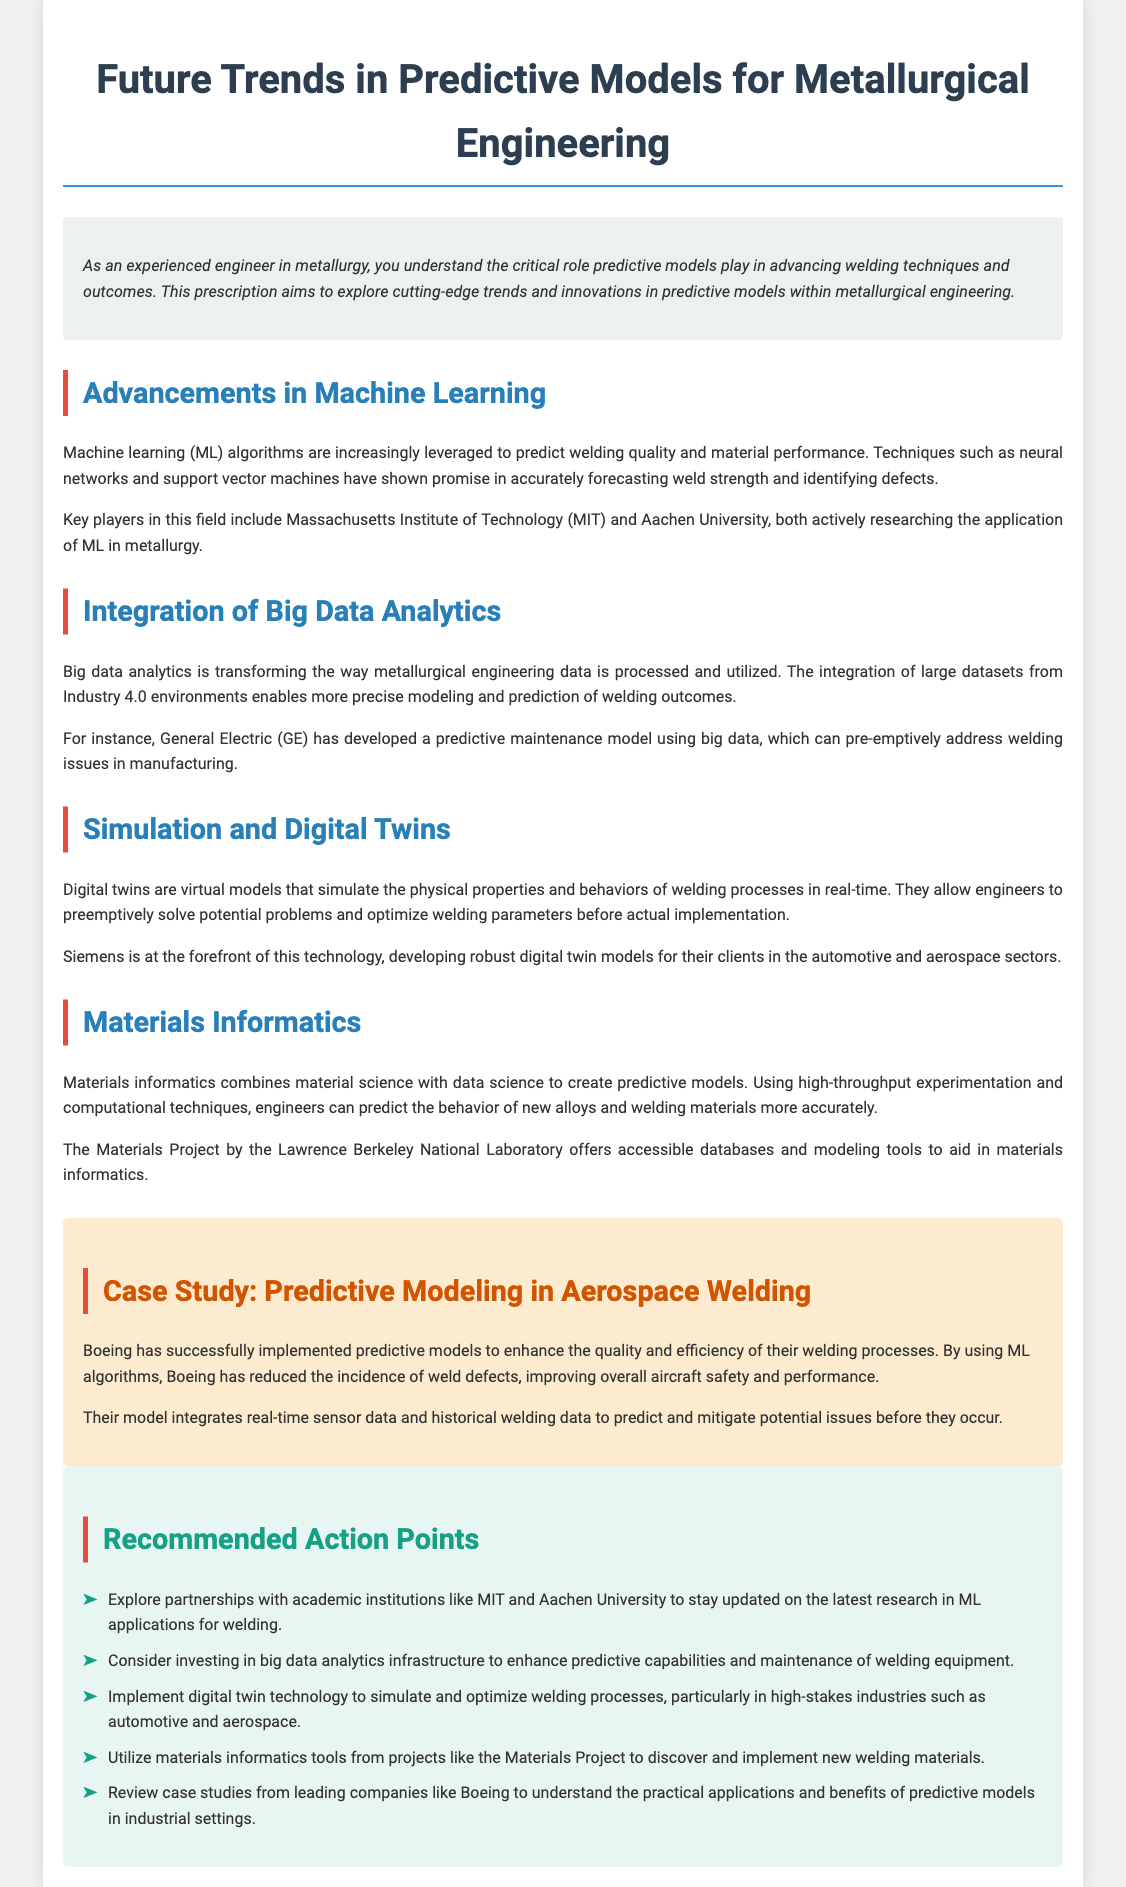What role do predictive models play in welding? Predictive models are critical in advancing welding techniques and outcomes.
Answer: Advancing welding techniques Which institutions are researching machine learning applications in metallurgy? Massachusetts Institute of Technology (MIT) and Aachen University are key players in researching machine learning applications in metallurgy.
Answer: MIT and Aachen University What technology is being developed by Siemens for welding processes? Siemens is developing robust digital twin models for their clients in the automotive and aerospace sectors.
Answer: Digital twin models What type of data is integrated into Boeing's predictive models? Boeing's model integrates real-time sensor data and historical welding data.
Answer: Real-time sensor data and historical welding data What is the main focus of materials informatics? Materials informatics combines material science with data science to create predictive models.
Answer: Predictive models How has predictive modeling impacted Boeing's welding quality? Predictive models have reduced the incidence of weld defects.
Answer: Reduced incidence of weld defects 